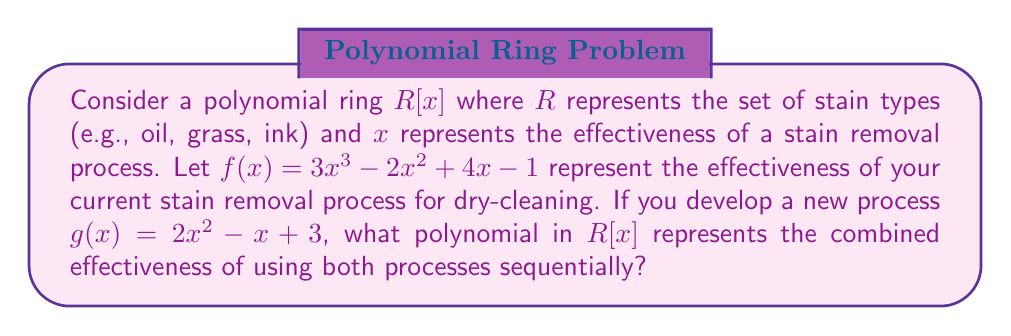Teach me how to tackle this problem. To solve this problem, we need to understand that the sequential application of two stain removal processes can be modeled as the composition of their respective polynomials in the ring $R[x]$.

1) We are given two polynomials:
   $f(x) = 3x^3 - 2x^2 + 4x - 1$ (current process)
   $g(x) = 2x^2 - x + 3$ (new process)

2) To find the combined effectiveness, we need to compute $f(g(x))$, which means we replace every $x$ in $f(x)$ with $g(x)$.

3) Let's calculate step by step:

   $f(g(x)) = 3(g(x))^3 - 2(g(x))^2 + 4(g(x)) - 1$

4) First, let's calculate $(g(x))^2$ and $(g(x))^3$:
   
   $(g(x))^2 = (2x^2 - x + 3)^2 = 4x^4 - 4x^3 + 12x^2 - 2x^3 + x^2 - 3x + 12x^2 - 6x + 9$
              $= 4x^4 - 6x^3 + 25x^2 - 9x + 9$

   $(g(x))^3 = (2x^2 - x + 3)(4x^4 - 6x^3 + 25x^2 - 9x + 9)$
              $= 8x^6 - 12x^5 + 50x^4 - 18x^3 + 18x^2$
              $- 4x^5 + 6x^4 - 25x^3 + 9x^2 - 9x$
              $+ 12x^4 - 18x^3 + 75x^2 - 27x + 27$
              $= 8x^6 - 16x^5 + 68x^4 - 61x^3 + 102x^2 - 36x + 27$

5) Now, let's substitute these back into our original equation:

   $f(g(x)) = 3(8x^6 - 16x^5 + 68x^4 - 61x^3 + 102x^2 - 36x + 27)$
             $- 2(4x^4 - 6x^3 + 25x^2 - 9x + 9)$
             $+ 4(2x^2 - x + 3) - 1$

6) Simplifying:

   $f(g(x)) = 24x^6 - 48x^5 + 204x^4 - 183x^3 + 306x^2 - 108x + 81$
             $- 8x^4 + 12x^3 - 50x^2 + 18x - 18$
             $+ 8x^2 - 4x + 12 - 1$

7) Combining like terms:

   $f(g(x)) = 24x^6 - 48x^5 + 196x^4 - 171x^3 + 264x^2 - 94x + 74$

This polynomial represents the combined effectiveness of using both stain removal processes sequentially.
Answer: $f(g(x)) = 24x^6 - 48x^5 + 196x^4 - 171x^3 + 264x^2 - 94x + 74$ 